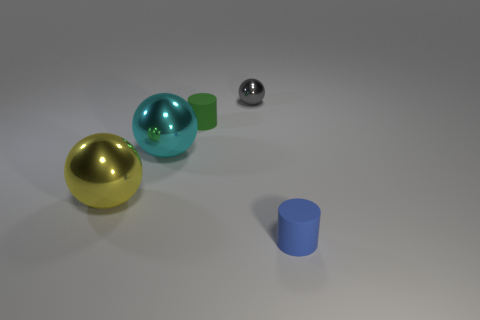Add 1 purple objects. How many objects exist? 6 Subtract all spheres. How many objects are left? 2 Subtract all tiny green objects. Subtract all large cyan metal objects. How many objects are left? 3 Add 1 large balls. How many large balls are left? 3 Add 2 large cyan metal balls. How many large cyan metal balls exist? 3 Subtract 1 gray spheres. How many objects are left? 4 